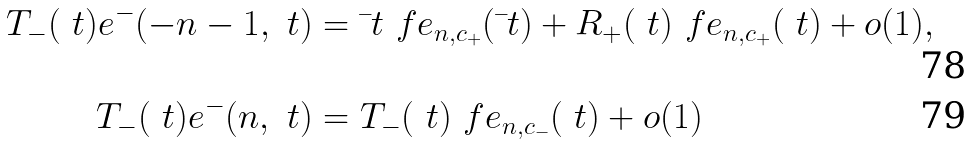Convert formula to latex. <formula><loc_0><loc_0><loc_500><loc_500>T _ { - } ( \ t ) e ^ { - } ( - n - 1 , \ t ) & = \bar { \ } t \ f e _ { n , c _ { + } } ( \bar { \ } t ) + R _ { + } ( \ t ) \ f e _ { n , c _ { + } } ( \ t ) + o ( 1 ) , \\ T _ { - } ( \ t ) e ^ { - } ( n , \ t ) & = T _ { - } ( \ t ) \ f e _ { n , c _ { - } } ( \ t ) + o ( 1 )</formula> 